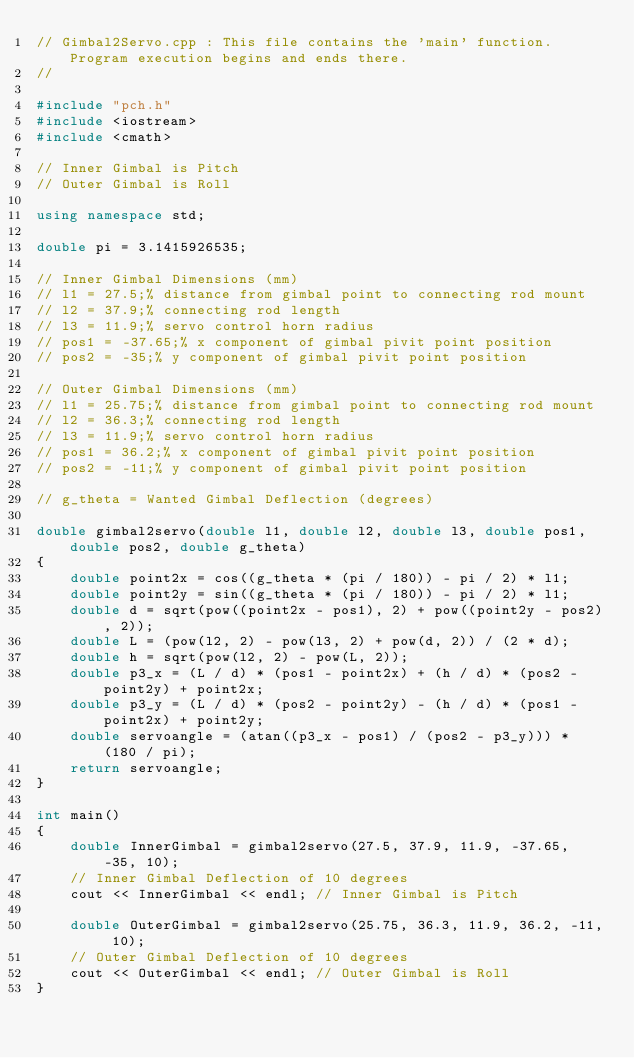<code> <loc_0><loc_0><loc_500><loc_500><_C++_>// Gimbal2Servo.cpp : This file contains the 'main' function. Program execution begins and ends there.
//

#include "pch.h"
#include <iostream>
#include <cmath>

// Inner Gimbal is Pitch
// Outer Gimbal is Roll

using namespace std;

double pi = 3.1415926535;

// Inner Gimbal Dimensions (mm)
// l1 = 27.5;% distance from gimbal point to connecting rod mount
// l2 = 37.9;% connecting rod length
// l3 = 11.9;% servo control horn radius
// pos1 = -37.65;% x component of gimbal pivit point position
// pos2 = -35;% y component of gimbal pivit point position

// Outer Gimbal Dimensions (mm)
// l1 = 25.75;% distance from gimbal point to connecting rod mount
// l2 = 36.3;% connecting rod length
// l3 = 11.9;% servo control horn radius
// pos1 = 36.2;% x component of gimbal pivit point position
// pos2 = -11;% y component of gimbal pivit point position

// g_theta = Wanted Gimbal Deflection (degrees)

double gimbal2servo(double l1, double l2, double l3, double pos1, double pos2, double g_theta)
{
	double point2x = cos((g_theta * (pi / 180)) - pi / 2) * l1;
	double point2y = sin((g_theta * (pi / 180)) - pi / 2) * l1;
	double d = sqrt(pow((point2x - pos1), 2) + pow((point2y - pos2), 2));
	double L = (pow(l2, 2) - pow(l3, 2) + pow(d, 2)) / (2 * d);
	double h = sqrt(pow(l2, 2) - pow(L, 2));
	double p3_x = (L / d) * (pos1 - point2x) + (h / d) * (pos2 - point2y) + point2x;
	double p3_y = (L / d) * (pos2 - point2y) - (h / d) * (pos1 - point2x) + point2y;
	double servoangle = (atan((p3_x - pos1) / (pos2 - p3_y))) * (180 / pi);
	return servoangle;
}

int main()
{
	double InnerGimbal = gimbal2servo(27.5, 37.9, 11.9, -37.65, -35, 10);
	// Inner Gimbal Deflection of 10 degrees
	cout << InnerGimbal << endl; // Inner Gimbal is Pitch

	double OuterGimbal = gimbal2servo(25.75, 36.3, 11.9, 36.2, -11, 10);
	// Outer Gimbal Deflection of 10 degrees
	cout << OuterGimbal << endl; // Outer Gimbal is Roll
}
</code> 